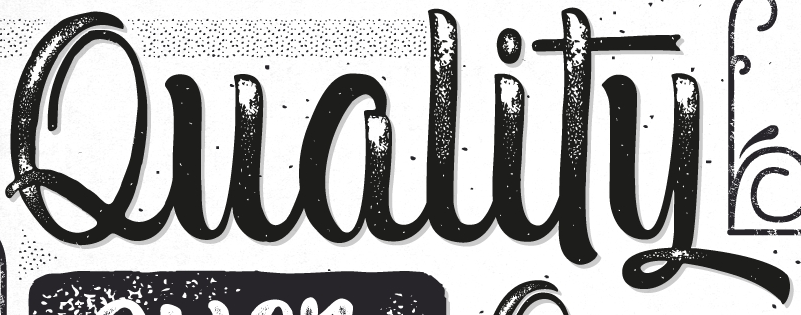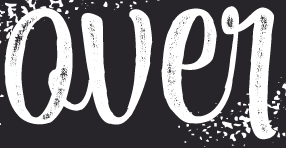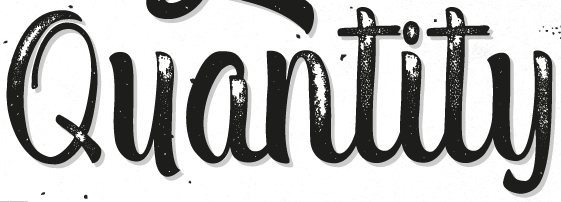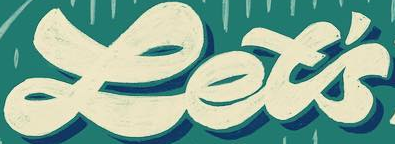What text is displayed in these images sequentially, separated by a semicolon? Quality; Qver; Quantity; Let's 